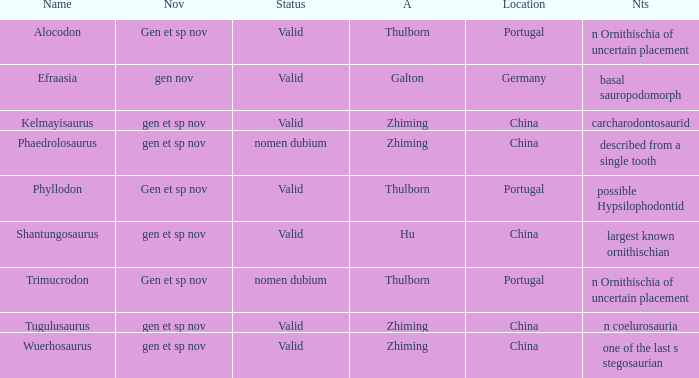What is the Novelty of the dinosaur, whose naming Author was Galton? Gen nov. 